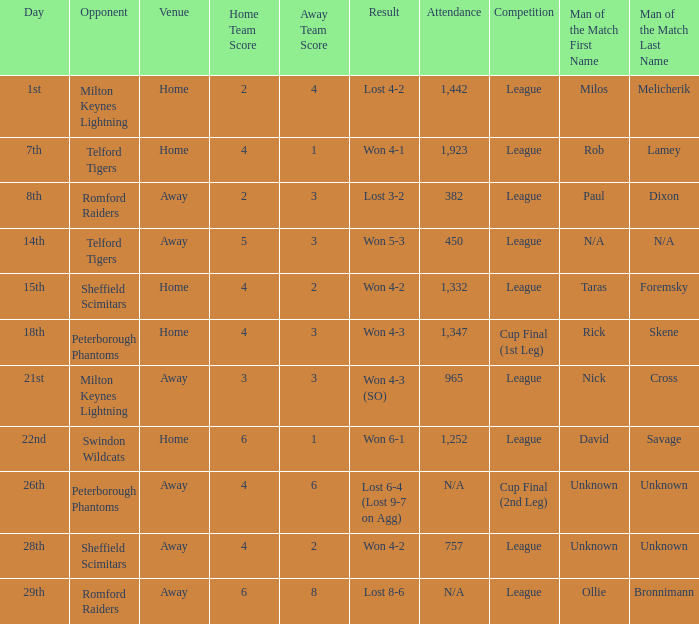On what date was the venue Away and the result was lost 6-4 (lost 9-7 on agg)? 26th. Can you parse all the data within this table? {'header': ['Day', 'Opponent', 'Venue', 'Home Team Score', 'Away Team Score', 'Result', 'Attendance', 'Competition', 'Man of the Match First Name', 'Man of the Match Last Name'], 'rows': [['1st', 'Milton Keynes Lightning', 'Home', '2', '4', 'Lost 4-2', '1,442', 'League', 'Milos', 'Melicherik'], ['7th', 'Telford Tigers', 'Home', '4', '1', 'Won 4-1', '1,923', 'League', 'Rob', 'Lamey'], ['8th', 'Romford Raiders', 'Away', '2', '3', 'Lost 3-2', '382', 'League', 'Paul', 'Dixon'], ['14th', 'Telford Tigers', 'Away', '5', '3', 'Won 5-3', '450', 'League', 'N/A', 'N/A'], ['15th', 'Sheffield Scimitars', 'Home', '4', '2', 'Won 4-2', '1,332', 'League', 'Taras', 'Foremsky'], ['18th', 'Peterborough Phantoms', 'Home', '4', '3', 'Won 4-3', '1,347', 'Cup Final (1st Leg)', 'Rick', 'Skene'], ['21st', 'Milton Keynes Lightning', 'Away', '3', '3', 'Won 4-3 (SO)', '965', 'League', 'Nick', 'Cross'], ['22nd', 'Swindon Wildcats', 'Home', '6', '1', 'Won 6-1', '1,252', 'League', 'David', 'Savage'], ['26th', 'Peterborough Phantoms', 'Away', '4', '6', 'Lost 6-4 (Lost 9-7 on Agg)', 'N/A', 'Cup Final (2nd Leg)', 'Unknown', 'Unknown'], ['28th', 'Sheffield Scimitars', 'Away', '4', '2', 'Won 4-2', '757', 'League', 'Unknown', 'Unknown'], ['29th', 'Romford Raiders', 'Away', '6', '8', 'Lost 8-6', 'N/A', 'League', 'Ollie', 'Bronnimann']]} 